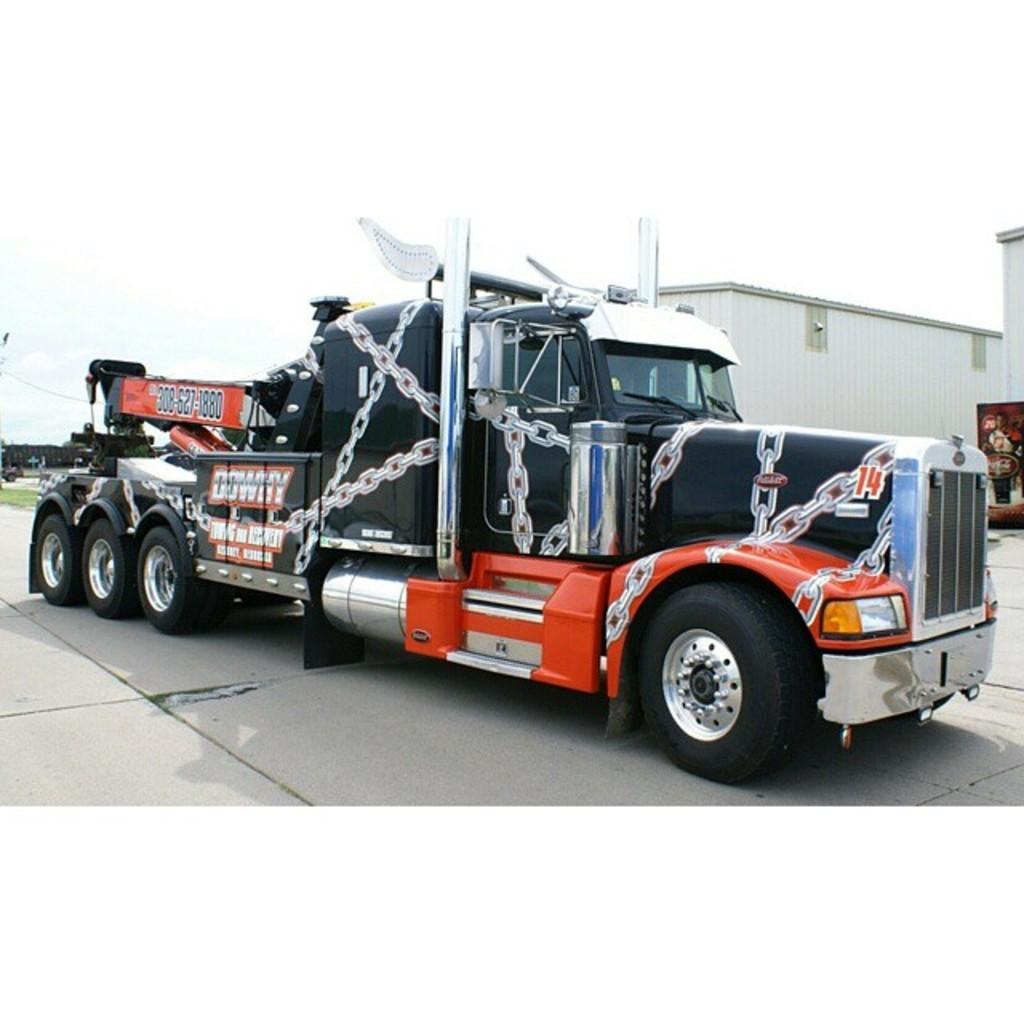What is the main subject of the image? The main subject of the image is a truck. What else can be seen in the image besides the truck? There are buildings and trees in the background of the image. How would you describe the sky in the image? The sky is cloudy in the image. How many ladybugs can be seen on the truck in the image? There are no ladybugs present on the truck in the image. What type of ornament is hanging from the truck's rearview mirror in the image? There is no ornament hanging from the truck's rearview mirror in the image. 